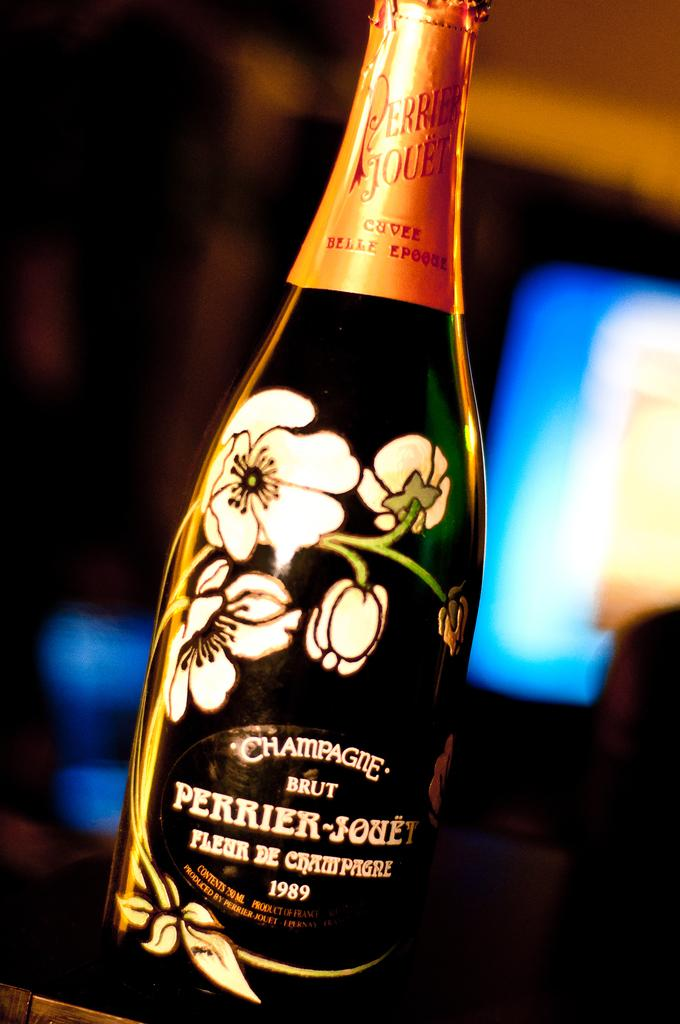<image>
Present a compact description of the photo's key features. A bottle of "BRUT PERRIER-JOUET" champagne has flowers on the front. 